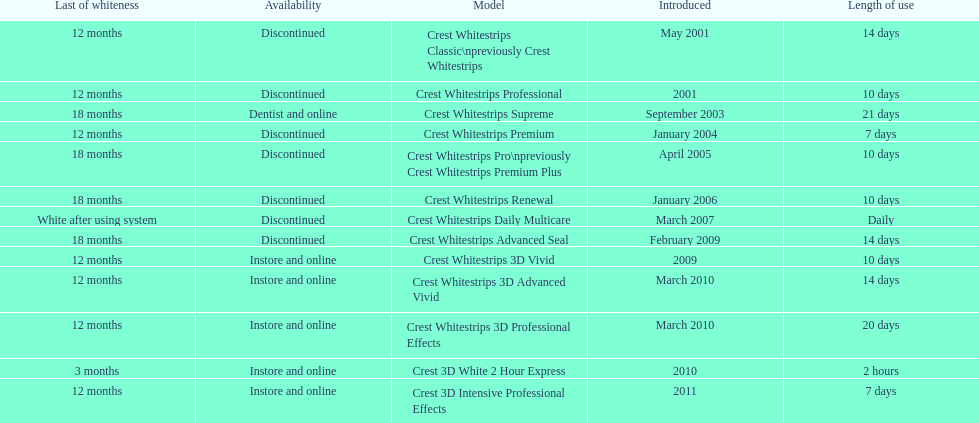Does the crest white strips classic last at least one year? Yes. 